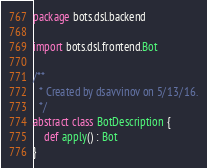Convert code to text. <code><loc_0><loc_0><loc_500><loc_500><_Scala_>package bots.dsl.backend

import bots.dsl.frontend.Bot

/**
  * Created by dsavvinov on 5/13/16.
  */
abstract class BotDescription {
    def apply() : Bot
}
</code> 